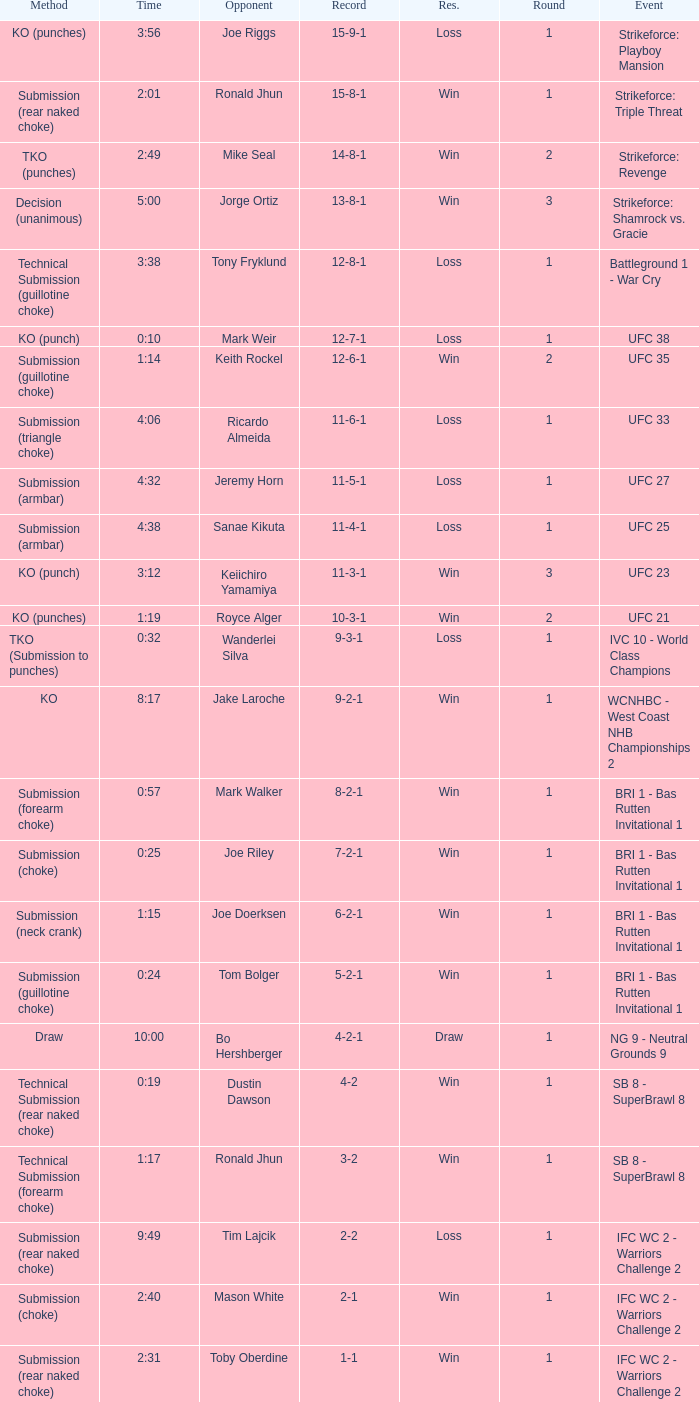Who was the opponent when the fight had a time of 0:10? Mark Weir. 